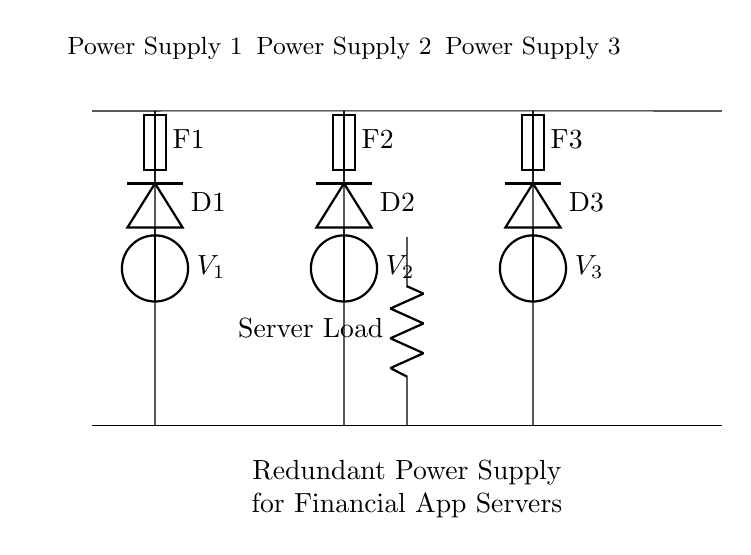What type of circuit is shown? The circuit is a parallel circuit, indicated by multiple branches connecting the same two points, allowing for multiple paths for current to flow.
Answer: Parallel How many power supplies are present? There are three power supplies shown in the diagram, labeled as V1, V2, and V3.
Answer: Three What is the purpose of the fuses in this circuit? Fuses are used here as protective devices that can interrupt the circuit in case of overcurrent, ensuring that the system remains safe by preventing damage to components.
Answer: Protection What component ensures current only flows in one direction? The diodes D1, D2, and D3 ensure that the current flows in one direction, preventing reverse flow that could potentially damage the circuit.
Answer: Diodes If one power supply fails, what happens to the server load? The server load can still receive current from the remaining operational power supplies, ensuring that it continues to function without interruption.
Answer: Continues to function How many diodes are included in the circuit? There are three diodes in the circuit, each corresponding to one of the power supplies, labeled D1, D2, and D3.
Answer: Three What would happen if all power supplies fail at the same time? If all power supplies fail simultaneously, the server load would lose power, as there would be no voltage source left to supply current.
Answer: Loss of power 